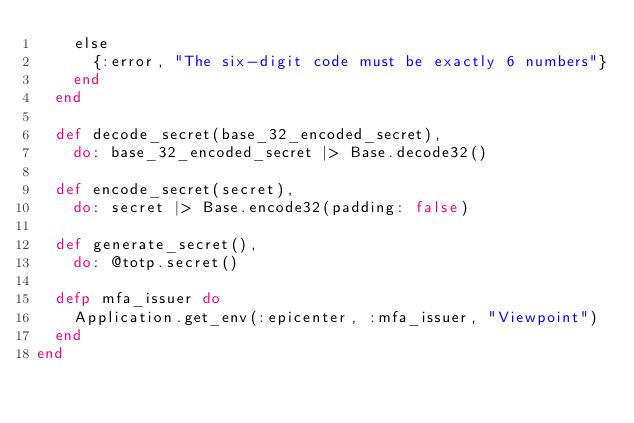<code> <loc_0><loc_0><loc_500><loc_500><_Elixir_>    else
      {:error, "The six-digit code must be exactly 6 numbers"}
    end
  end

  def decode_secret(base_32_encoded_secret),
    do: base_32_encoded_secret |> Base.decode32()

  def encode_secret(secret),
    do: secret |> Base.encode32(padding: false)

  def generate_secret(),
    do: @totp.secret()

  defp mfa_issuer do
    Application.get_env(:epicenter, :mfa_issuer, "Viewpoint")
  end
end
</code> 